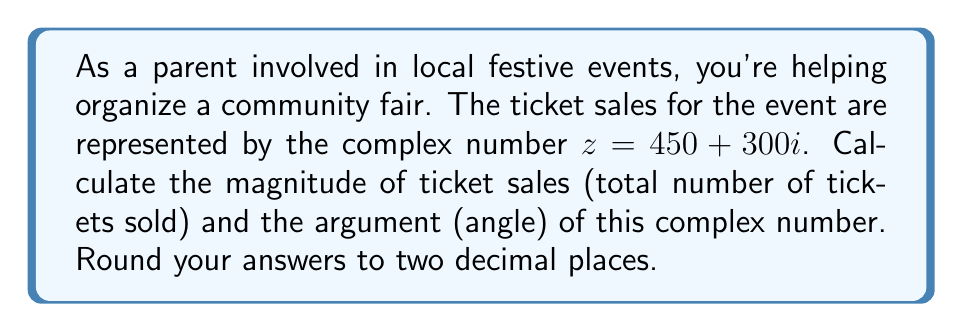Provide a solution to this math problem. To find the magnitude and argument of the complex number $z = 450 + 300i$, we'll follow these steps:

1. Magnitude (modulus):
   The magnitude of a complex number $z = a + bi$ is given by the formula:
   $$|z| = \sqrt{a^2 + b^2}$$
   
   In this case, $a = 450$ and $b = 300$:
   $$|z| = \sqrt{450^2 + 300^2} = \sqrt{202500 + 90000} = \sqrt{292500} \approx 540.83$$

2. Argument (angle):
   The argument of a complex number is the angle it makes with the positive real axis. It's calculated using the arctangent function:
   $$\arg(z) = \tan^{-1}\left(\frac{b}{a}\right)$$
   
   However, we need to be careful about the quadrant. Since both $a$ and $b$ are positive, we're in the first quadrant, so we can use this formula directly:
   $$\arg(z) = \tan^{-1}\left(\frac{300}{450}\right) = \tan^{-1}\left(\frac{2}{3}\right) \approx 0.5880$$
   
   To convert this to degrees, multiply by $\frac{180}{\pi}$:
   $$0.5880 \times \frac{180}{\pi} \approx 33.69°$$

The magnitude represents the total number of tickets sold, while the argument represents the angle of the complex number in the complex plane, which could be interpreted as the ratio of different types of tickets sold (e.g., adult vs. child tickets).
Answer: Magnitude: 540.83 tickets
Argument: 33.69° 